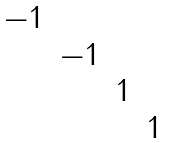Convert formula to latex. <formula><loc_0><loc_0><loc_500><loc_500>\begin{matrix} - 1 & & & \\ & - 1 & & \\ & & 1 & \\ & & & 1 \end{matrix}</formula> 